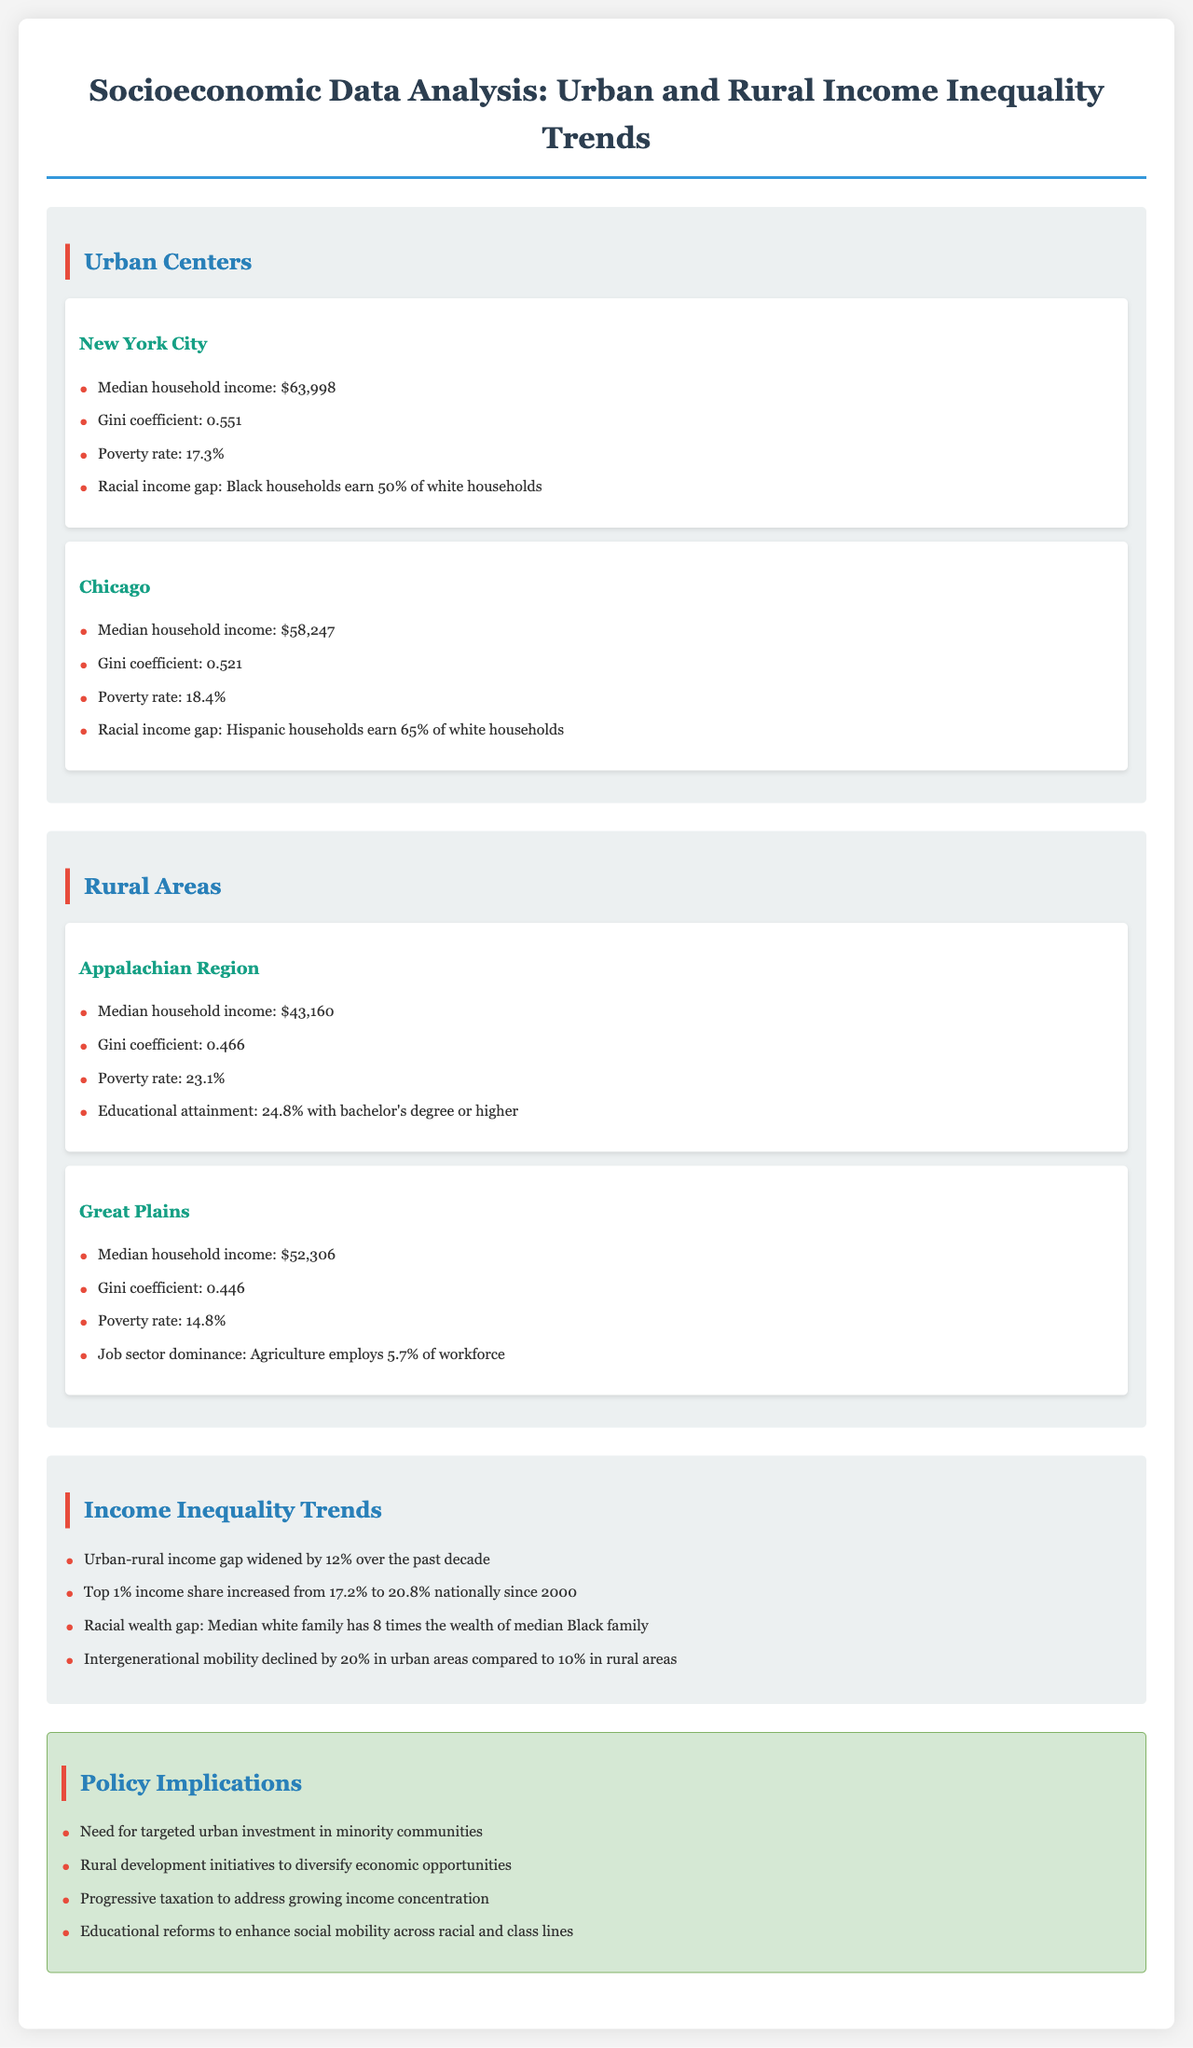What is the median household income in New York City? The median household income is a specific number provided for New York City, which is $63,998.
Answer: $63,998 What is the Gini coefficient for Chicago? The Gini coefficient is a statistical measure of income inequality, and for Chicago, it is stated as 0.521.
Answer: 0.521 What percentage of households in the Appalachian Region live in poverty? The poverty rate is explicitly mentioned for the Appalachian Region, which is 23.1%.
Answer: 23.1% How much has the urban-rural income gap widened over the past decade? The document states that the urban-rural income gap has widened by 12% over the specified time frame.
Answer: 12% What is the racial income gap percentage in New York City? The racial income gap specifically stated in New York City indicates that Black households earn 50% of white households.
Answer: 50% What is the median household income in the Great Plains? The document provides a specific figure for median household income in the Great Plains, which is $52,306.
Answer: $52,306 What percentage of the workforce in the Great Plains is employed in agriculture? The employment statistic for agriculture in the Great Plains is provided as 5.7% of the workforce.
Answer: 5.7% What is the racial wealth gap described in the document? The document specifies that the median white family has 8 times the wealth of the median Black family, which illustrates the racial wealth gap.
Answer: 8 times What educational reform is suggested in the policy implications? The document suggests educational reforms aimed at enhancing social mobility across racial and class lines.
Answer: Educational reforms 